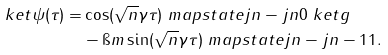Convert formula to latex. <formula><loc_0><loc_0><loc_500><loc_500>\ k e t { \psi ( \tau ) } = & \cos ( \sqrt { n } \gamma \tau ) \ m a p s t a t e { j } { n - j } { n } { 0 } \ k e t { g } \\ & - \i m \sin ( \sqrt { n } \gamma \tau ) \ m a p s t a t e { j } { n - j } { n - 1 } { 1 } .</formula> 